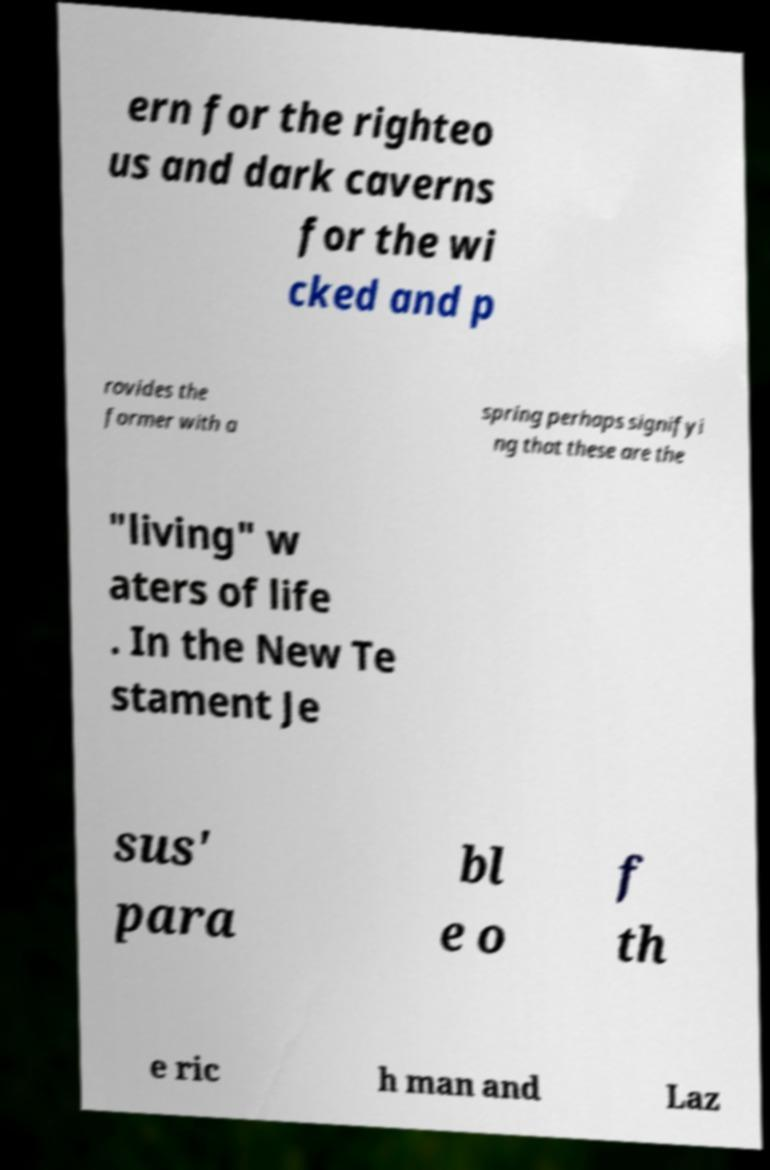Please identify and transcribe the text found in this image. ern for the righteo us and dark caverns for the wi cked and p rovides the former with a spring perhaps signifyi ng that these are the "living" w aters of life . In the New Te stament Je sus' para bl e o f th e ric h man and Laz 